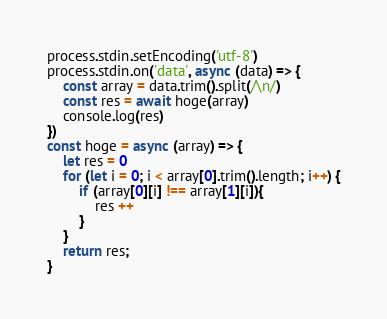<code> <loc_0><loc_0><loc_500><loc_500><_JavaScript_>process.stdin.setEncoding('utf-8')
process.stdin.on('data', async (data) => {
    const array = data.trim().split(/\n/)
    const res = await hoge(array)
    console.log(res)
})
const hoge = async (array) => {
    let res = 0
    for (let i = 0; i < array[0].trim().length; i++) {
        if (array[0][i] !== array[1][i]){
            res ++
        }
    }
    return res;
}
</code> 